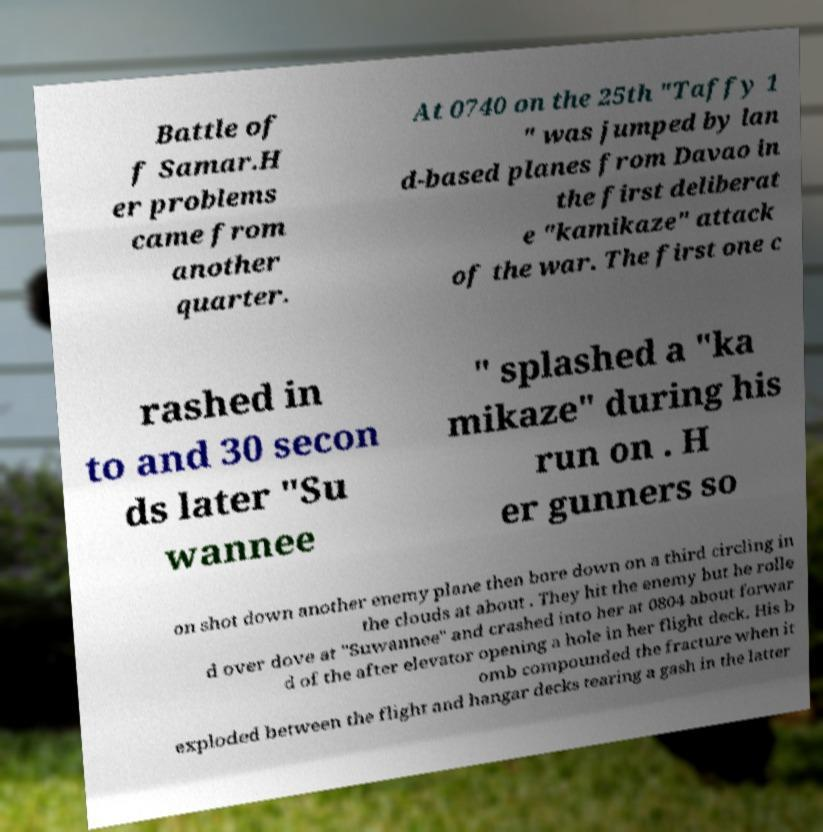There's text embedded in this image that I need extracted. Can you transcribe it verbatim? Battle of f Samar.H er problems came from another quarter. At 0740 on the 25th "Taffy 1 " was jumped by lan d-based planes from Davao in the first deliberat e "kamikaze" attack of the war. The first one c rashed in to and 30 secon ds later "Su wannee " splashed a "ka mikaze" during his run on . H er gunners so on shot down another enemy plane then bore down on a third circling in the clouds at about . They hit the enemy but he rolle d over dove at "Suwannee" and crashed into her at 0804 about forwar d of the after elevator opening a hole in her flight deck. His b omb compounded the fracture when it exploded between the flight and hangar decks tearing a gash in the latter 